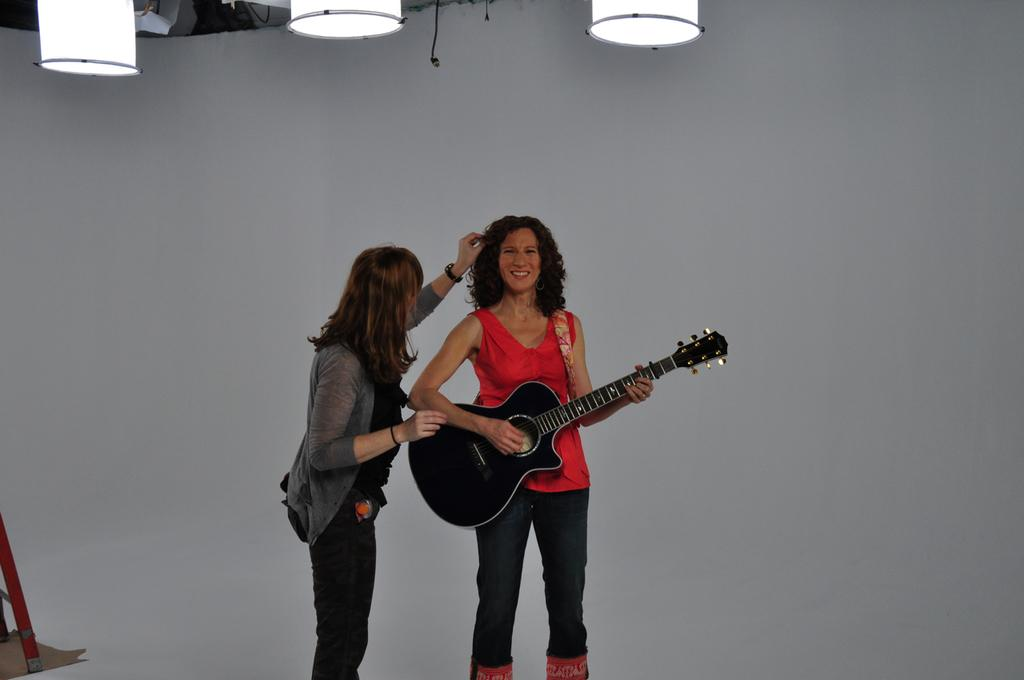What can be seen in the image that provides illumination? There are lights in the image. How many people are present in the image? There are two people standing in the image. What is the woman holding in the image? A woman is holding a guitar in the image. What type of wristwatch is the woman wearing in the image? There is no wristwatch visible on the woman in the image. How many ducks are swimming in the background of the image? There are no ducks present in the image. What type of oil is being used to lubricate the guitar strings in the image? There is no indication of any oil being used in the image; the woman is simply holding a guitar. 